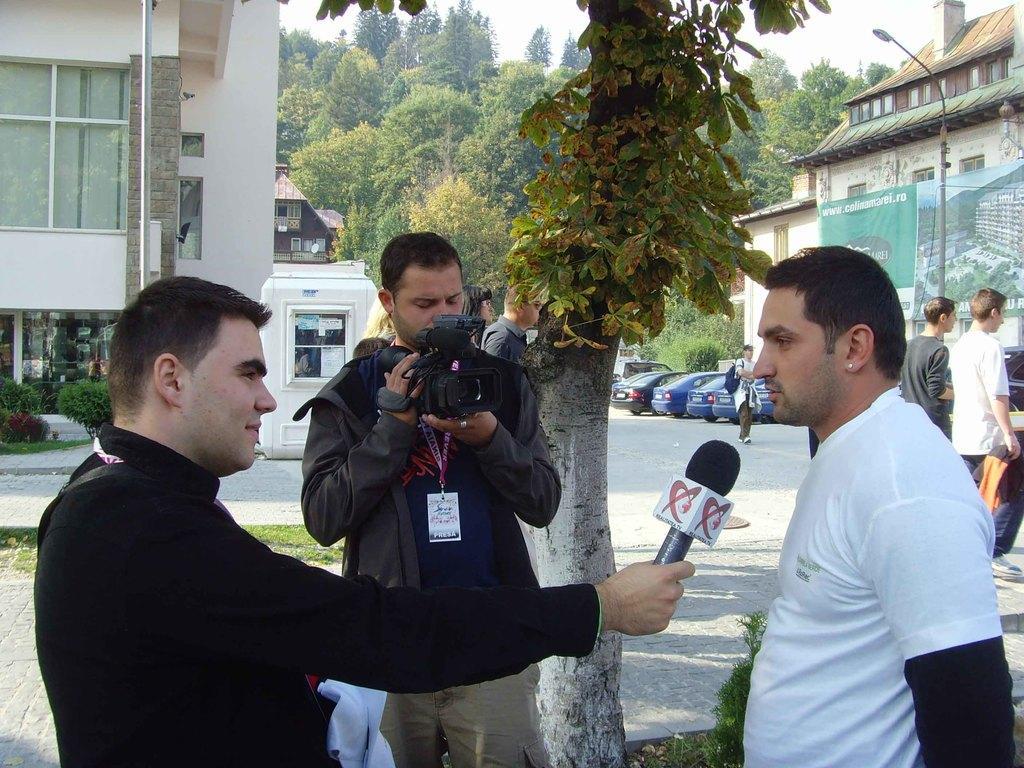How would you summarize this image in a sentence or two? In this picture there is a person with black shirt is standing and holding the microphone. The person with black jacket is standing and holding the camera. At the back there are group of people walking and there are trees, buildings and vehicles on the road and poles on the footpath. On the left side of the image there is a hoarding. At the top there is sky. At the bottom there is a road. 